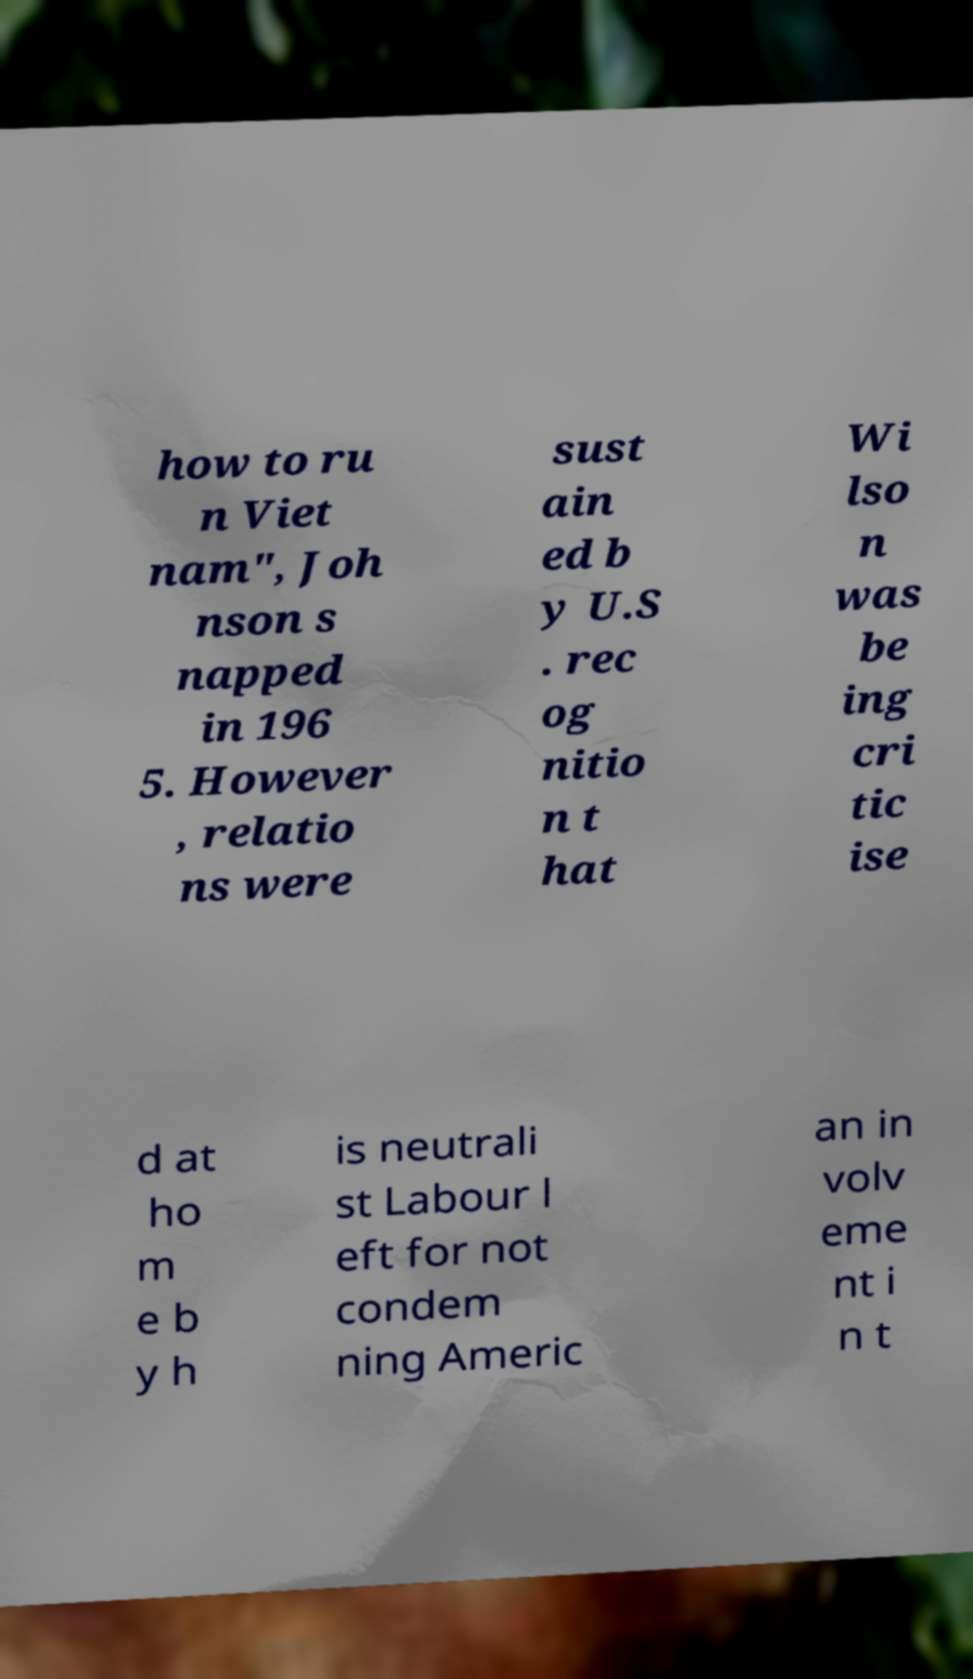Could you assist in decoding the text presented in this image and type it out clearly? how to ru n Viet nam", Joh nson s napped in 196 5. However , relatio ns were sust ain ed b y U.S . rec og nitio n t hat Wi lso n was be ing cri tic ise d at ho m e b y h is neutrali st Labour l eft for not condem ning Americ an in volv eme nt i n t 